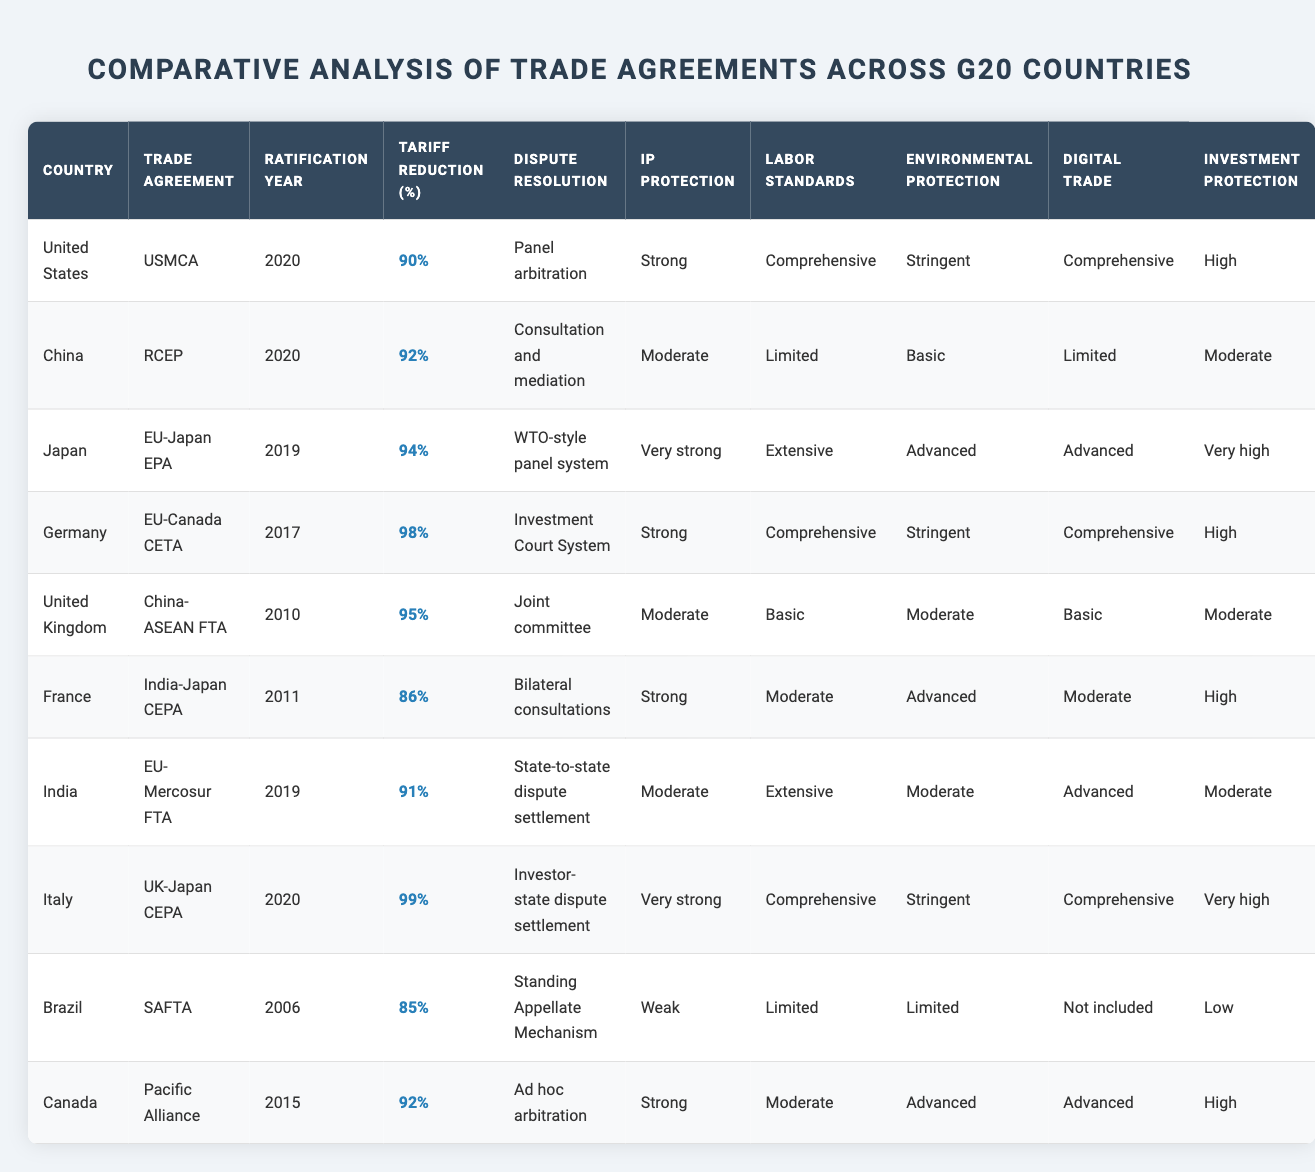What is the trade agreement ratified by the United Kingdom? The table indicates that the trade agreement ratified by the United Kingdom is the UK-Japan CEPA.
Answer: UK-Japan CEPA Which country has the highest tariff reduction percentage? By looking at the column for tariff reduction, Germany has the highest percentage at 98%.
Answer: 98% True or False: Brazil has a trade agreement that includes comprehensive digital trade provisions. The table shows Brazil's trade agreement is under the Pacific Alliance, which lists digital trade provisions as advanced, not comprehensive. Therefore, the statement is false.
Answer: False Which countries have more than 90% tariff reduction in their trade agreements? The countries listed with a tariff reduction of more than 90% are United States (90%), China (92%), Japan (94%), Germany (98%), United Kingdom (95%), and Italy (99%). Counting these, we find 6 countries in total.
Answer: 6 What is the average ratification year of the trade agreements listed? To find the average, sum the years of ratification (2020 + 2020 + 2019 + 2017 + 2010 + 2011 + 2019 + 2020 + 2006 + 2015) which equals 2020. Then divide by the number of trade agreements (10), giving us an average of 2019.
Answer: 2019 Which country has a dispute resolution mechanism described as "Investment Court System"? The table indicates that Germany has a dispute resolution mechanism described as "Investment Court System."
Answer: Germany Is there a trade agreement among the listed countries that does not include any environmental protection measures? Yes, Brazil is listed with limited environmental protection measures under its trade agreement.
Answer: Yes List the countries that have "Very strong" intellectual property protection in their trade agreements. The countries with "Very strong" intellectual property protection are Japan and Italy, as indicated in the IP protection column.
Answer: Japan, Italy Which trade agreement has the lowest investment protection level? According to the table, the trade agreement with the lowest investment protection level is Brazil's agreement under the Pacific Alliance, which is categorized as low.
Answer: Pacific Alliance Among the listed countries, which has the most extensive labor standards provisions? The table shows that the United States, Germany, India, and Italy have extensive labor standards provisions, with each classified as such.
Answer: United States, Germany, India, Italy What percentage of tariff reduction does India achieve in its trade agreement? The tariff reduction percentage for India's trade agreement (India-Japan CEPA) is indicated as 86%.
Answer: 86% 